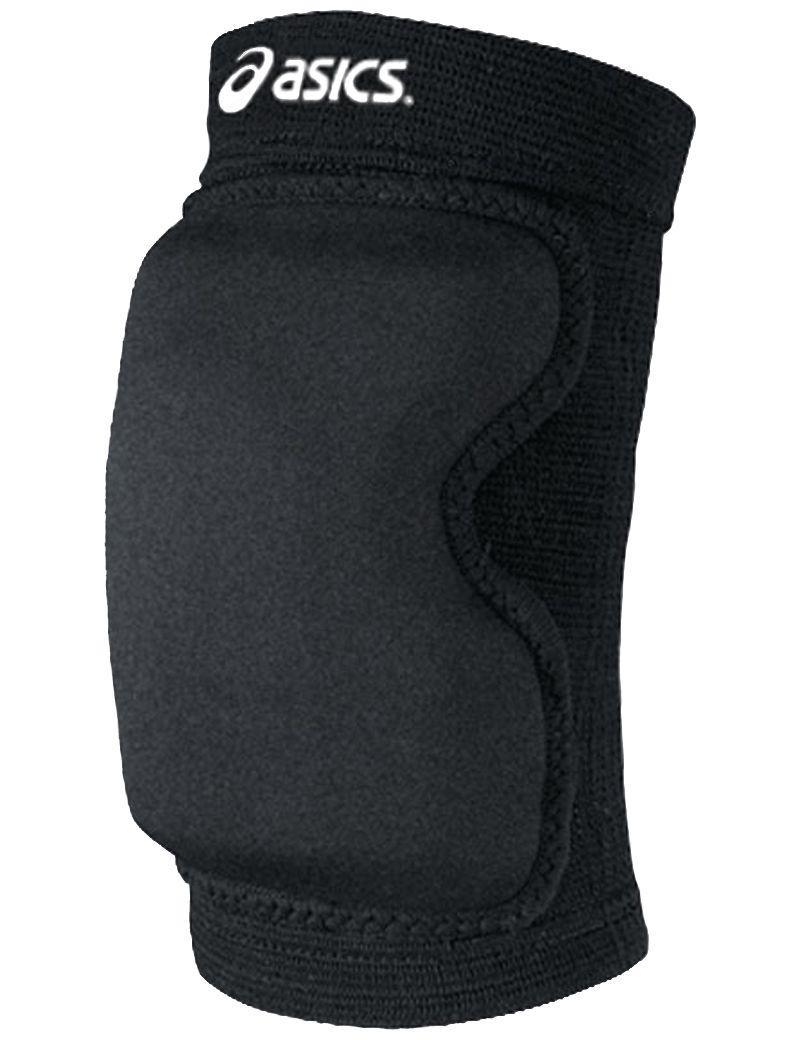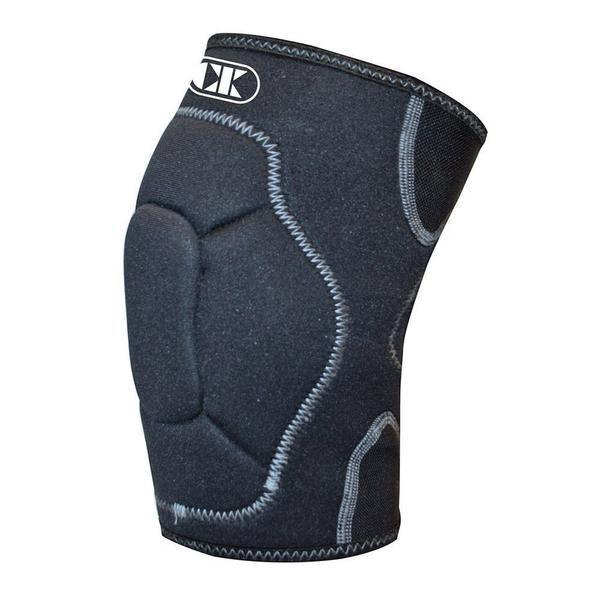The first image is the image on the left, the second image is the image on the right. Assess this claim about the two images: "There are two black knee pads.". Correct or not? Answer yes or no. Yes. The first image is the image on the left, the second image is the image on the right. Considering the images on both sides, is "Images each show one knee pad, and pads are turned facing the same direction." valid? Answer yes or no. Yes. 